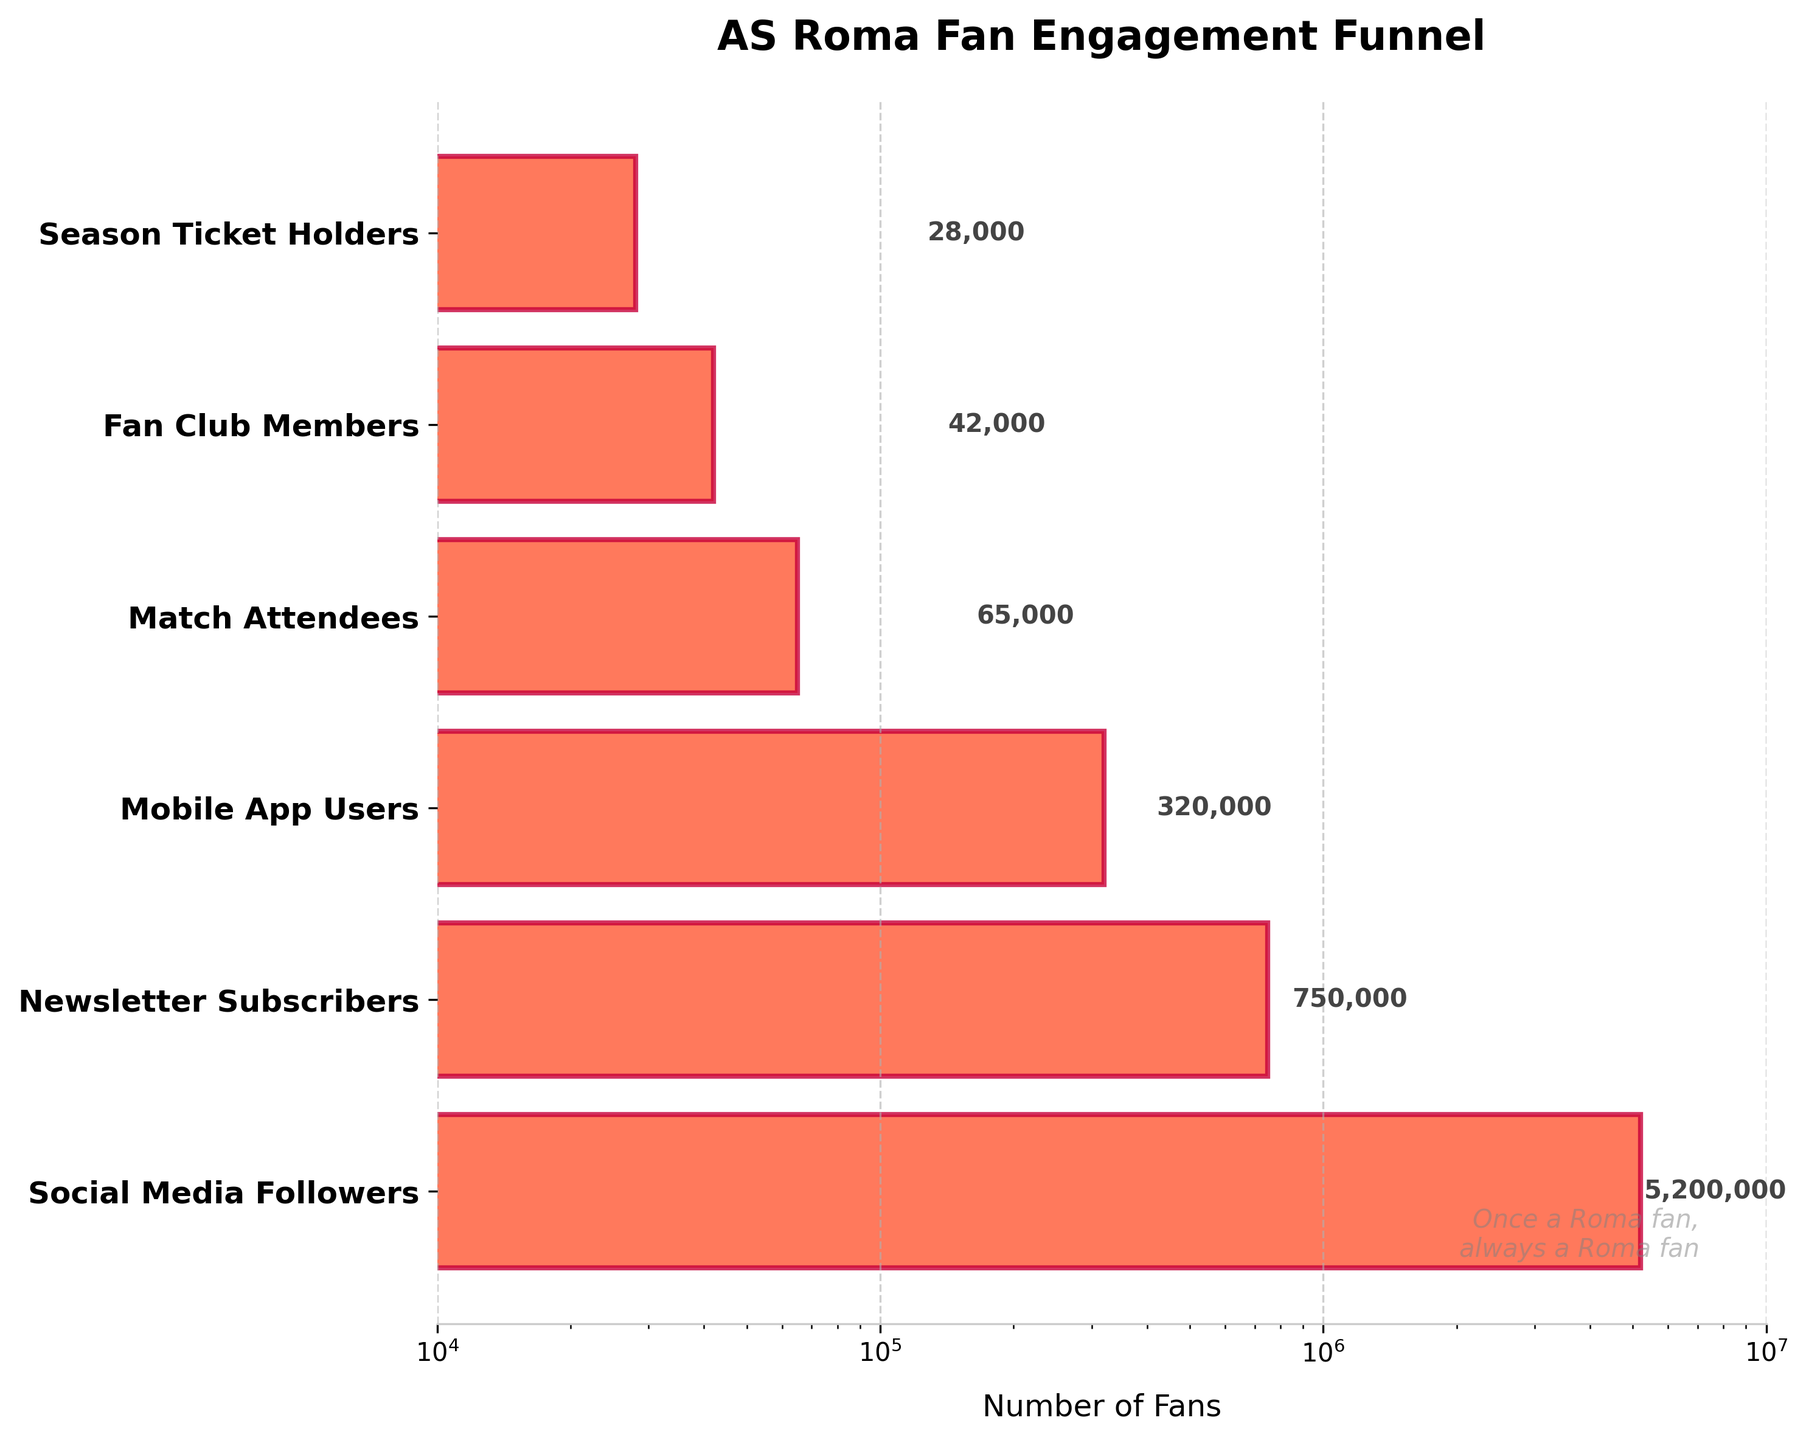What's the title of the figure? The title is usually placed at the top of the figure. Here, it reads "AS Roma Fan Engagement Funnel".
Answer: AS Roma Fan Engagement Funnel How many stages are shown in the fan engagement funnel? By counting the number of labeled stages on the y-axis, we see there are six entries, which are "Social Media Followers," "Newsletter Subscribers," "Mobile App Users," "Match Attendees," "Fan Club Members," and "Season Ticket Holders."
Answer: Six stages Which stage has the highest number of fans? The stage with the highest number will have the longest bar. "Social Media Followers" has the highest number of fans.
Answer: Social Media Followers What's the number of "Season Ticket Holders"? Reading the value label next to the respective stage "Season Ticket Holders," we see it is 28,000.
Answer: 28,000 Compare the number of "Mobile App Users" and "Match Attendees." Which is greater? "Mobile App Users" has a longer bar compared to "Match Attendees," thus having a higher number.
Answer: Mobile App Users What is the difference between "Newsletter Subscribers" and "Match Attendees"? The number for "Newsletter Subscribers" is 750,000 and for "Match Attendees" is 65,000. Subtracting these gives 750,000 - 65,000 = 685,000.
Answer: 685,000 How does the number of "Fan Club Members" compare to "Mobile App Users"? "Fan Club Members" has 42,000 fans while "Mobile App Users" has 320,000. This means "Mobile App Users" are greater.
Answer: Mobile App Users What is the proportion of "Fan Club Members" to "Social Media Followers"? Divide the number of "Fan Club Members" (42,000) by the number of "Social Media Followers" (5,200,000): 42,000 / 5,200,000 = 0.0081, or about 0.81%.
Answer: 0.81% Considering the funnel stages, at which stage do the highest number of AS Roma fans exit? This involves tracking the drop between each successive stage. The largest drop is from "Social Media Followers" (5,200,000) to "Newsletter Subscribers" (750,000), a difference of 4,450,000.
Answer: From Social Media Followers to Newsletter Subscribers 